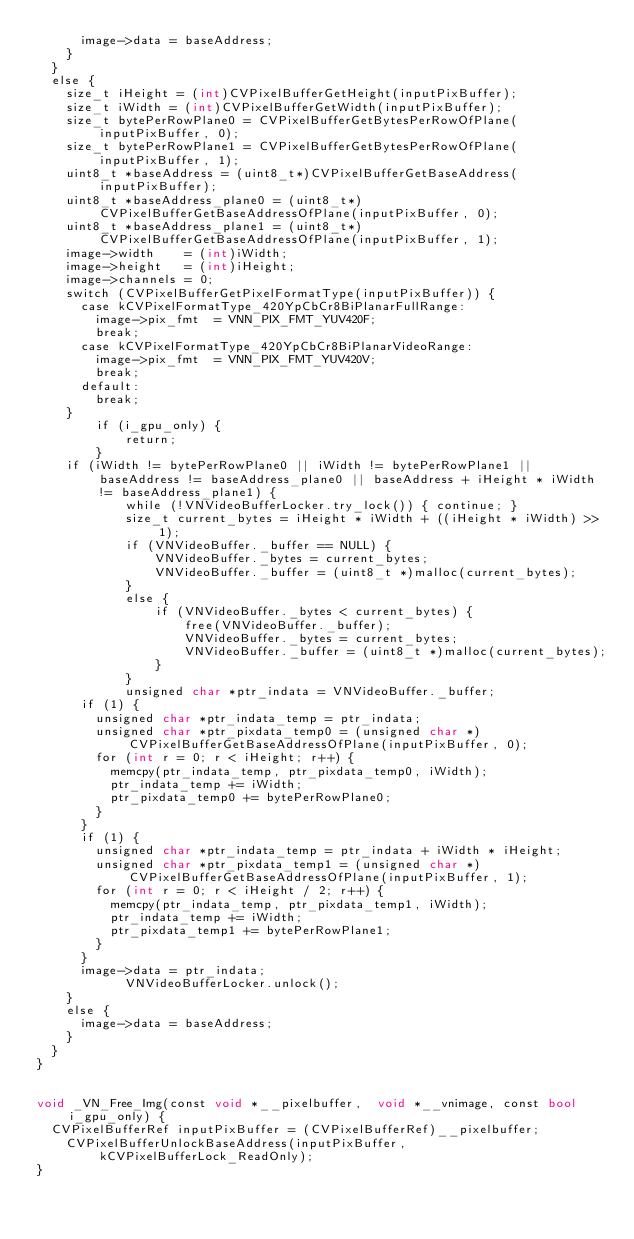Convert code to text. <code><loc_0><loc_0><loc_500><loc_500><_ObjectiveC_>			image->data = baseAddress;
		}
	}
	else {
		size_t iHeight = (int)CVPixelBufferGetHeight(inputPixBuffer);
		size_t iWidth = (int)CVPixelBufferGetWidth(inputPixBuffer);
		size_t bytePerRowPlane0 = CVPixelBufferGetBytesPerRowOfPlane(inputPixBuffer, 0);
		size_t bytePerRowPlane1 = CVPixelBufferGetBytesPerRowOfPlane(inputPixBuffer, 1);
		uint8_t *baseAddress = (uint8_t*)CVPixelBufferGetBaseAddress(inputPixBuffer);
		uint8_t *baseAddress_plane0 = (uint8_t*)CVPixelBufferGetBaseAddressOfPlane(inputPixBuffer, 0);
		uint8_t *baseAddress_plane1 = (uint8_t*)CVPixelBufferGetBaseAddressOfPlane(inputPixBuffer, 1);
		image->width    = (int)iWidth;
		image->height   = (int)iHeight;
		image->channels = 0;
		switch (CVPixelBufferGetPixelFormatType(inputPixBuffer)) {
			case kCVPixelFormatType_420YpCbCr8BiPlanarFullRange:
				image->pix_fmt  = VNN_PIX_FMT_YUV420F;
				break;
			case kCVPixelFormatType_420YpCbCr8BiPlanarVideoRange:
				image->pix_fmt  = VNN_PIX_FMT_YUV420V;
				break;
			default:
				break;
		}
        if (i_gpu_only) {
            return;
        }
		if (iWidth != bytePerRowPlane0 || iWidth != bytePerRowPlane1 || baseAddress != baseAddress_plane0 || baseAddress + iHeight * iWidth != baseAddress_plane1) {
            while (!VNVideoBufferLocker.try_lock()) { continue; }
            size_t current_bytes = iHeight * iWidth + ((iHeight * iWidth) >> 1);
            if (VNVideoBuffer._buffer == NULL) {
                VNVideoBuffer._bytes = current_bytes;
                VNVideoBuffer._buffer = (uint8_t *)malloc(current_bytes);
            }
            else {
                if (VNVideoBuffer._bytes < current_bytes) {
                    free(VNVideoBuffer._buffer);
                    VNVideoBuffer._bytes = current_bytes;
                    VNVideoBuffer._buffer = (uint8_t *)malloc(current_bytes);
                }
            }
            unsigned char *ptr_indata = VNVideoBuffer._buffer;
			if (1) {
				unsigned char *ptr_indata_temp = ptr_indata;
				unsigned char *ptr_pixdata_temp0 = (unsigned char *)CVPixelBufferGetBaseAddressOfPlane(inputPixBuffer, 0);
				for (int r = 0; r < iHeight; r++) {
					memcpy(ptr_indata_temp, ptr_pixdata_temp0, iWidth);
					ptr_indata_temp += iWidth;
					ptr_pixdata_temp0 += bytePerRowPlane0;
				}
			}
			if (1) {
				unsigned char *ptr_indata_temp = ptr_indata + iWidth * iHeight;
				unsigned char *ptr_pixdata_temp1 = (unsigned char *)CVPixelBufferGetBaseAddressOfPlane(inputPixBuffer, 1);
				for (int r = 0; r < iHeight / 2; r++) {
					memcpy(ptr_indata_temp, ptr_pixdata_temp1, iWidth);
					ptr_indata_temp += iWidth;
					ptr_pixdata_temp1 += bytePerRowPlane1;
				}
			}
			image->data = ptr_indata;
            VNVideoBufferLocker.unlock();
		}
		else {
			image->data = baseAddress;
		}
	}
}


void _VN_Free_Img(const void *__pixelbuffer,  void *__vnimage, const bool i_gpu_only) {
	CVPixelBufferRef inputPixBuffer = (CVPixelBufferRef)__pixelbuffer;
    CVPixelBufferUnlockBaseAddress(inputPixBuffer, kCVPixelBufferLock_ReadOnly);
}
</code> 